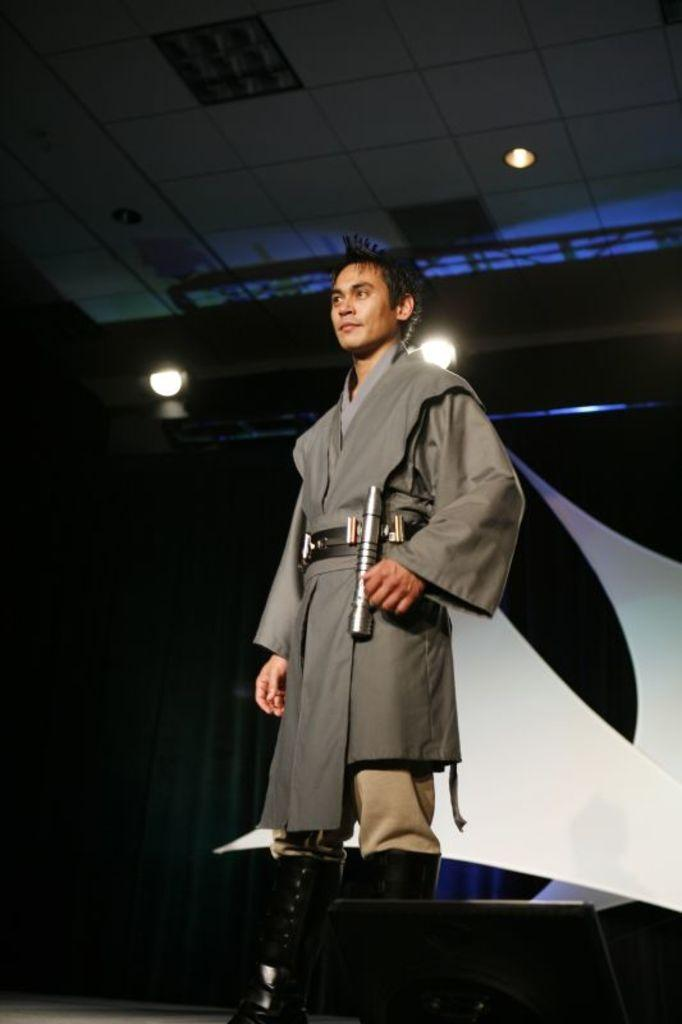What is the main subject of the image? There is a person standing in the image. Can you describe the background of the image? The background of the image is dark. What can be seen in addition to the person in the image? There are lights visible in the image. What type of structure is present in the image? There is a roof in the image. Are there any socks visible on the person in the image? There is no information about socks in the image, so we cannot determine if any are visible. --- 